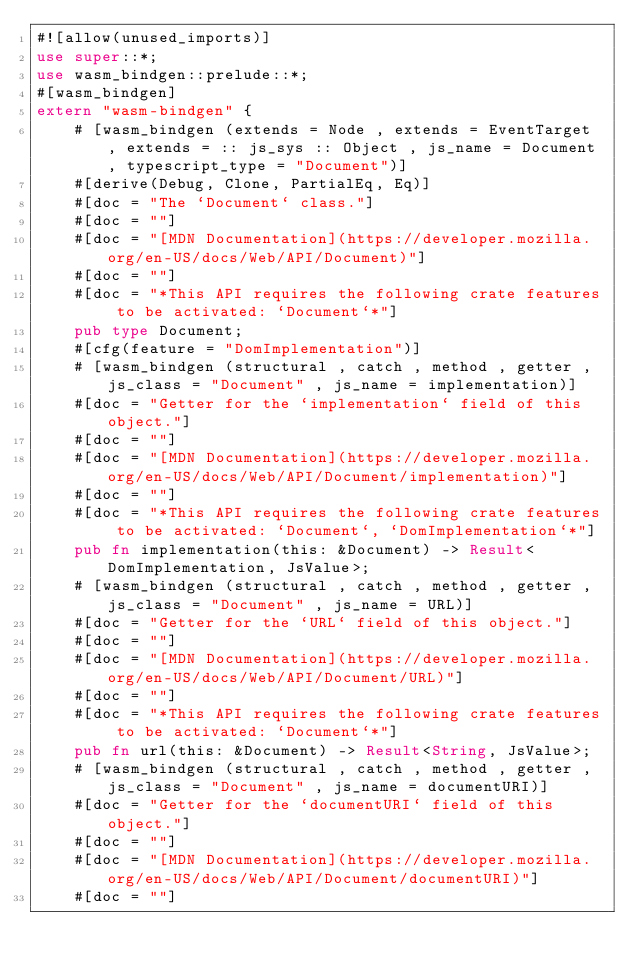<code> <loc_0><loc_0><loc_500><loc_500><_Rust_>#![allow(unused_imports)]
use super::*;
use wasm_bindgen::prelude::*;
#[wasm_bindgen]
extern "wasm-bindgen" {
    # [wasm_bindgen (extends = Node , extends = EventTarget , extends = :: js_sys :: Object , js_name = Document , typescript_type = "Document")]
    #[derive(Debug, Clone, PartialEq, Eq)]
    #[doc = "The `Document` class."]
    #[doc = ""]
    #[doc = "[MDN Documentation](https://developer.mozilla.org/en-US/docs/Web/API/Document)"]
    #[doc = ""]
    #[doc = "*This API requires the following crate features to be activated: `Document`*"]
    pub type Document;
    #[cfg(feature = "DomImplementation")]
    # [wasm_bindgen (structural , catch , method , getter , js_class = "Document" , js_name = implementation)]
    #[doc = "Getter for the `implementation` field of this object."]
    #[doc = ""]
    #[doc = "[MDN Documentation](https://developer.mozilla.org/en-US/docs/Web/API/Document/implementation)"]
    #[doc = ""]
    #[doc = "*This API requires the following crate features to be activated: `Document`, `DomImplementation`*"]
    pub fn implementation(this: &Document) -> Result<DomImplementation, JsValue>;
    # [wasm_bindgen (structural , catch , method , getter , js_class = "Document" , js_name = URL)]
    #[doc = "Getter for the `URL` field of this object."]
    #[doc = ""]
    #[doc = "[MDN Documentation](https://developer.mozilla.org/en-US/docs/Web/API/Document/URL)"]
    #[doc = ""]
    #[doc = "*This API requires the following crate features to be activated: `Document`*"]
    pub fn url(this: &Document) -> Result<String, JsValue>;
    # [wasm_bindgen (structural , catch , method , getter , js_class = "Document" , js_name = documentURI)]
    #[doc = "Getter for the `documentURI` field of this object."]
    #[doc = ""]
    #[doc = "[MDN Documentation](https://developer.mozilla.org/en-US/docs/Web/API/Document/documentURI)"]
    #[doc = ""]</code> 